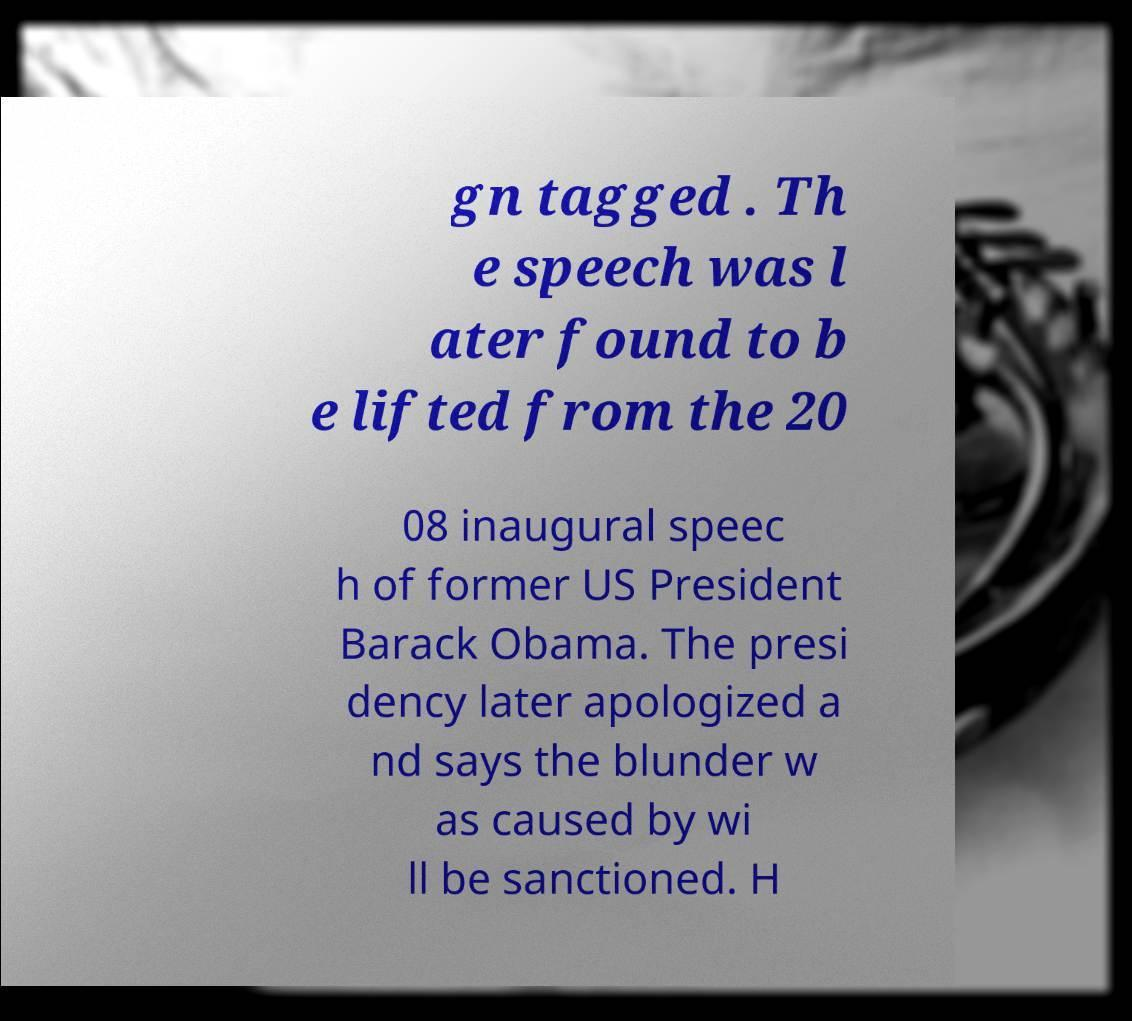Please read and relay the text visible in this image. What does it say? gn tagged . Th e speech was l ater found to b e lifted from the 20 08 inaugural speec h of former US President Barack Obama. The presi dency later apologized a nd says the blunder w as caused by wi ll be sanctioned. H 